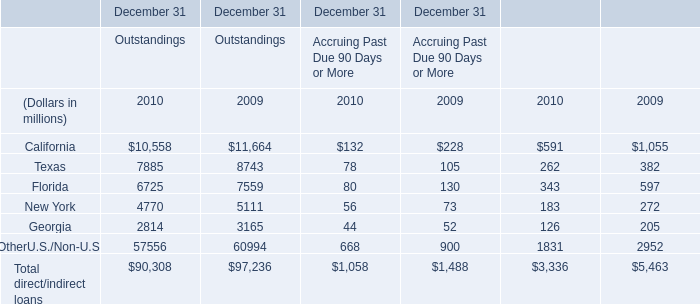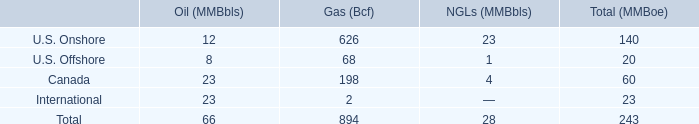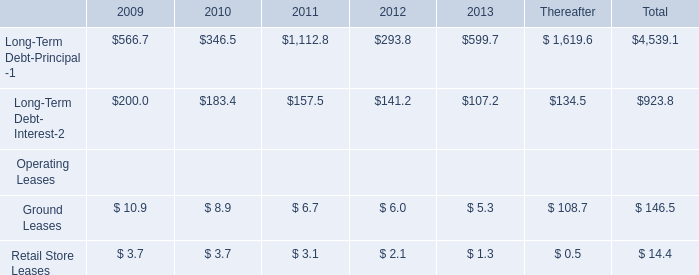What's the average of the Texas for Outstandings in the years where Long-Term Debt- Interest-2 is greater than 180? (in million) 
Computations: ((7885 + 8743) / 2)
Answer: 8314.0. 